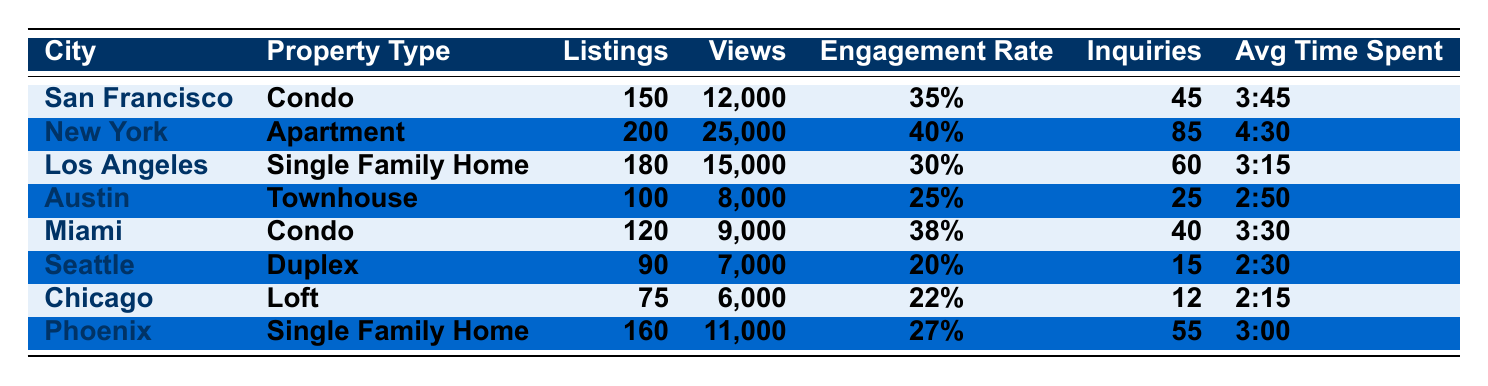What is the city with the highest number of inquiries? By looking at the 'Inquiries' column, we find that New York has the highest number at 85 inquiries.
Answer: New York Which property type has the highest engagement rate? The 'Engagement Rate' column shows New York's Apartment has the highest rate at 40%.
Answer: Apartment How many total listings are there across all cities? Adding all the listings together: 150 + 200 + 180 + 100 + 120 + 90 + 75 + 160 = 1075 total listings.
Answer: 1075 What is the average time spent on properties in Seattle? The 'Average Time Spent' for Seattle is already provided in the table as 2:30.
Answer: 2:30 Is the engagement rate for Austin higher than that of Miami? Austin has an engagement rate of 25%, whereas Miami's is 38%. So, it is false.
Answer: No Which city has the lowest number of views? The 'Views' for Seattle (7000) is the lowest among all cities.
Answer: Seattle What is the total number of inquiries for San Francisco and Miami combined? Adding inquiries from San Francisco (45) and Miami (40) gives us 85 inquiries in total.
Answer: 85 Which city has more views, Phoenix or Los Angeles? Phoenix has 11,000 views while Los Angeles has 15,000 views, so Los Angeles has more views.
Answer: Los Angeles What is the average engagement rate of all listed properties? The engagement rates are 0.35, 0.40, 0.30, 0.25, 0.38, 0.20, 0.22, 0.27. Summing these gives 2.07, dividing by 8 results in an average engagement rate of 0.25875, approximately 25.9%.
Answer: 25.9% Which city has the highest views per listing ratio? Calculating the views per listing ratio for each city, New York has the highest at 125 views per listing (25000/200).
Answer: New York 